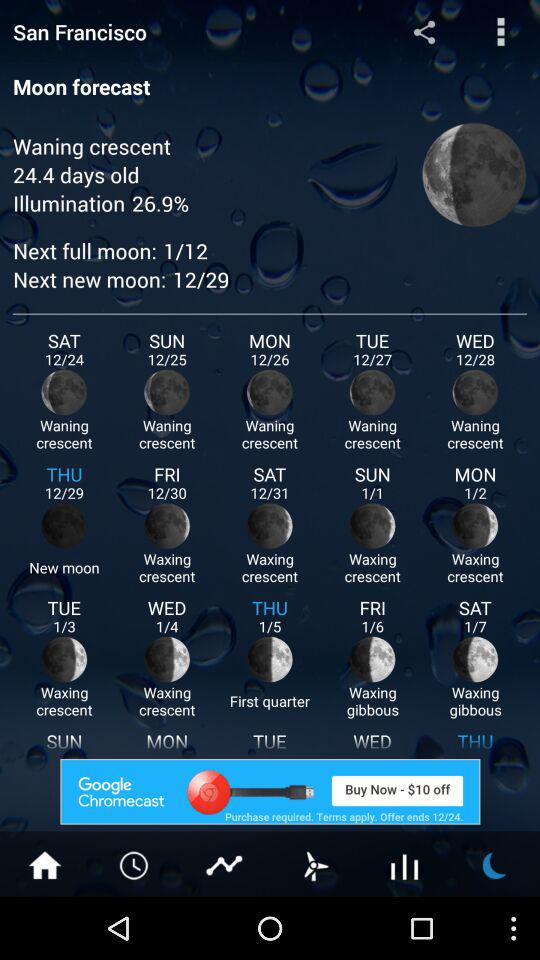What is the percentage of illumination? The illumination is 26.9%. 